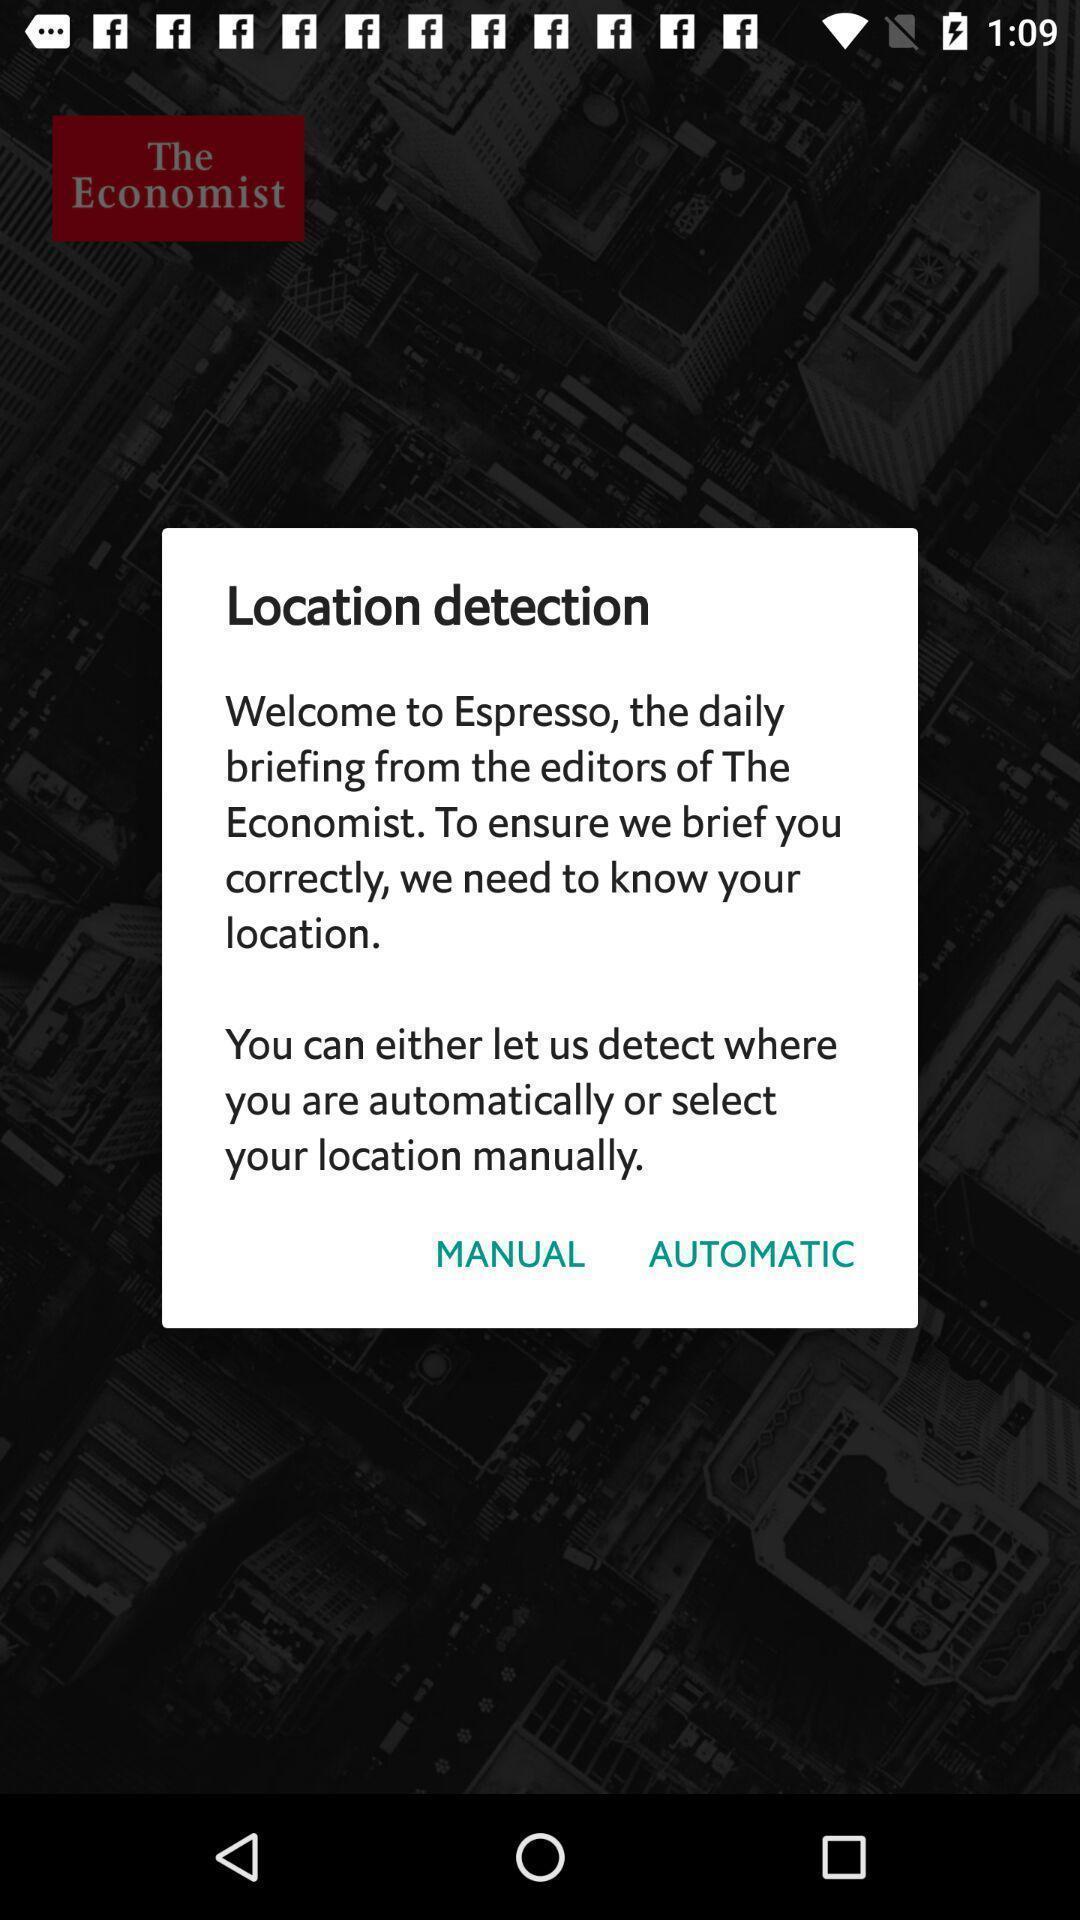Summarize the information in this screenshot. Pop-up asking manual or automatic location for a newspaper app. 